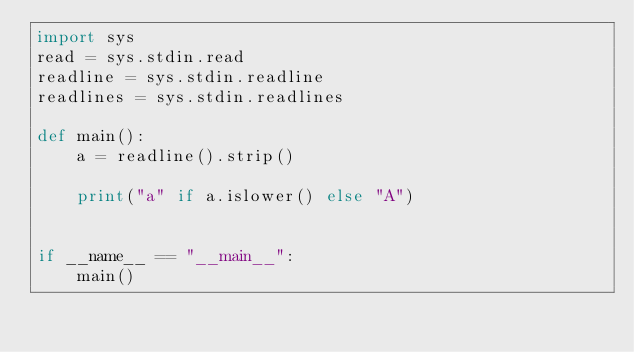<code> <loc_0><loc_0><loc_500><loc_500><_Python_>import sys
read = sys.stdin.read
readline = sys.stdin.readline
readlines = sys.stdin.readlines

def main():
    a = readline().strip()

    print("a" if a.islower() else "A")


if __name__ == "__main__":
    main()
</code> 